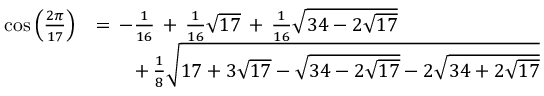<formula> <loc_0><loc_0><loc_500><loc_500>{ \begin{array} { r l } { \cos { \left ( { \frac { 2 \pi } { 1 7 } } \right ) } } & { = \, - { \frac { 1 } { 1 6 } } \, + \, { \frac { 1 } { 1 6 } } { \sqrt { 1 7 } } \, + \, { \frac { 1 } { 1 6 } } { \sqrt { 3 4 - 2 { \sqrt { 1 7 } } } } } \\ & { \quad + \, { \frac { 1 } { 8 } } { \sqrt { 1 7 + 3 { \sqrt { 1 7 } } - { \sqrt { 3 4 - 2 { \sqrt { 1 7 } } } } - 2 { \sqrt { 3 4 + 2 { \sqrt { 1 7 } } } } } } } \end{array} }</formula> 